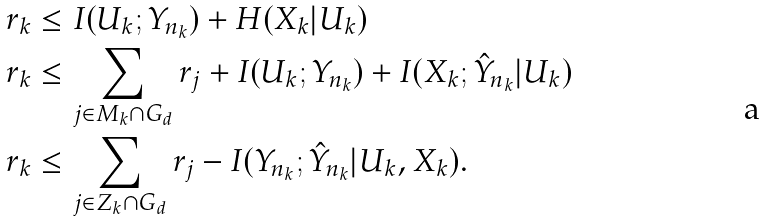Convert formula to latex. <formula><loc_0><loc_0><loc_500><loc_500>r _ { k } & \leq I ( U _ { k } ; Y _ { n _ { k } } ) + H ( X _ { k } | U _ { k } ) \\ r _ { k } & \leq \sum _ { j \in M _ { k } \cap G _ { d } } r _ { j } + I ( U _ { k } ; Y _ { n _ { k } } ) + I ( X _ { k } ; \hat { Y } _ { n _ { k } } | U _ { k } ) \\ r _ { k } & \leq \sum _ { j \in Z _ { k } \cap G _ { d } } r _ { j } - I ( Y _ { n _ { k } } ; \hat { Y } _ { n _ { k } } | U _ { k } , X _ { k } ) .</formula> 